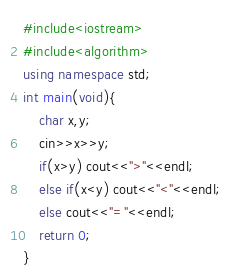<code> <loc_0><loc_0><loc_500><loc_500><_C++_>#include<iostream>
#include<algorithm>
using namespace std;
int main(void){
	char x,y;
	cin>>x>>y;
	if(x>y) cout<<">"<<endl;
	else if(x<y) cout<<"<"<<endl;
	else cout<<"="<<endl;
	return 0;
}</code> 